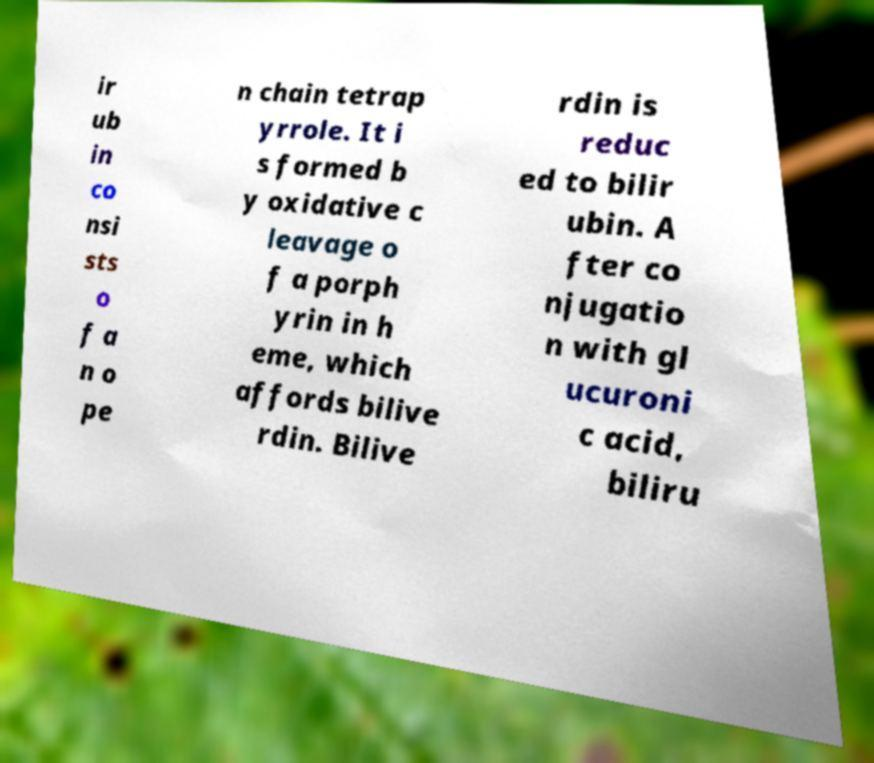For documentation purposes, I need the text within this image transcribed. Could you provide that? ir ub in co nsi sts o f a n o pe n chain tetrap yrrole. It i s formed b y oxidative c leavage o f a porph yrin in h eme, which affords bilive rdin. Bilive rdin is reduc ed to bilir ubin. A fter co njugatio n with gl ucuroni c acid, biliru 